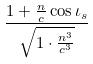<formula> <loc_0><loc_0><loc_500><loc_500>\frac { 1 + \frac { n } { c } \cos \iota _ { s } } { \sqrt { 1 \cdot \frac { n ^ { 3 } } { c ^ { 3 } } } }</formula> 